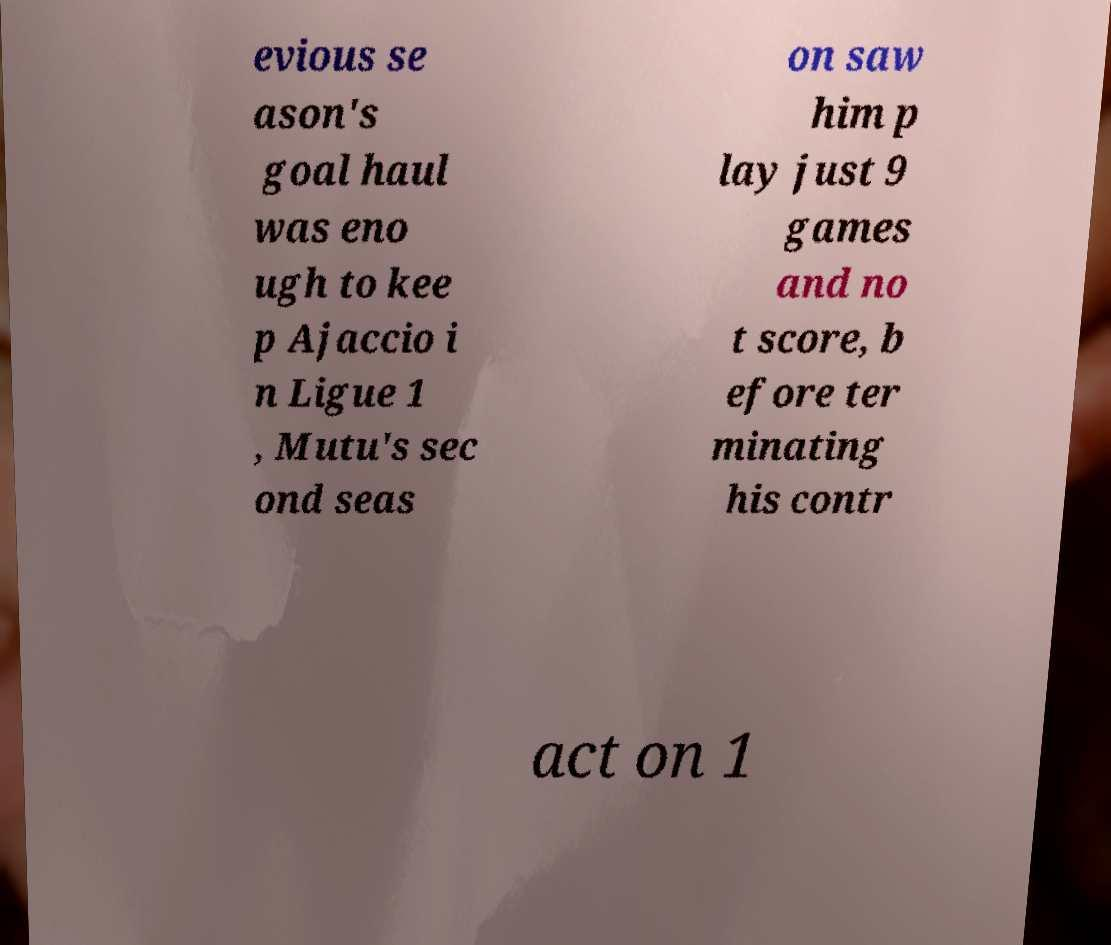Could you assist in decoding the text presented in this image and type it out clearly? evious se ason's goal haul was eno ugh to kee p Ajaccio i n Ligue 1 , Mutu's sec ond seas on saw him p lay just 9 games and no t score, b efore ter minating his contr act on 1 